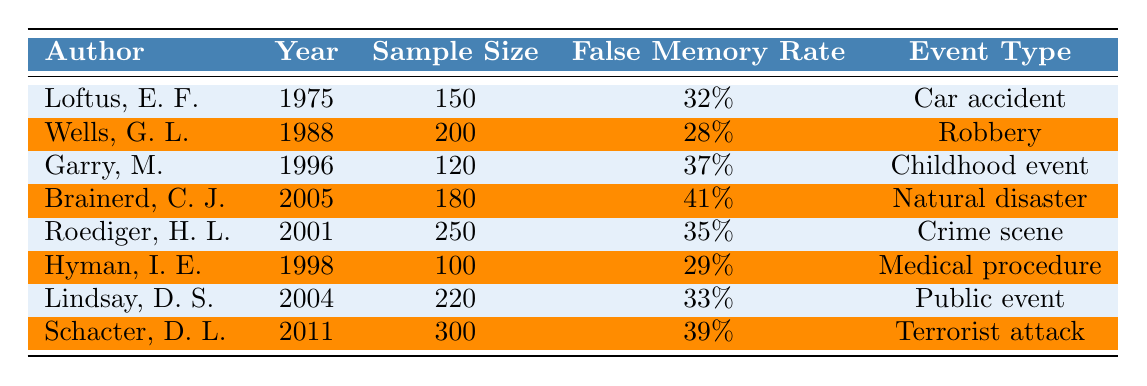What is the false memory rate for the study conducted by Brainerd, C. J.? The table lists the false memory rate column, and under Brainerd, C. J., it shows 41%.
Answer: 41% Which event type has the highest false memory rate according to the studies? By examining the false memory rates, the highest value is 41% for the event type "natural disaster" from Brainerd, C. J.
Answer: Natural disaster How many studies have a false memory rate of 35% or higher? The studies with false memory rates of 0.35 or higher are: Loftus (32%), Garry (37%), Brainerd (41%), Roediger (35%), Lindsay (33%), and Schacter (39%). This totals to 5 studies.
Answer: 5 What is the average sample size across all studies? The sample sizes are 150, 200, 120, 180, 250, 100, 220, and 300. Sum these values (150 + 200 + 120 + 180 + 250 + 100 + 220 + 300 = 1520) and divide by 8 (the number of studies), resulting in an average of 190.
Answer: 190 Is the false memory rate for the "terrorist attack" event higher than that of the "robbery" event? The false memory rate for "terrorist attack" by Schacter is 39% and for "robbery" by Wells is 28%. Since 39% is greater than 28%, it is true that the rate is higher.
Answer: Yes If we combine the false memory rates of the studies by Garry, M. and Hyman, I. E., what is the result? Garry has a false memory rate of 37% and Hyman has 29%. Adding these gives us 37% + 29% = 66%.
Answer: 66% Which author's study has the lowest sample size, and what is the associated false memory rate? Hyman, I. E. has the lowest sample size of 100 with a false memory rate of 29%.
Answer: Hyman, I. E.; 29% What year did Wells, G. L. conduct their study? By locating the row for Wells, G. L., the year listed is 1988.
Answer: 1988 How many studies covered events that are related to crime? Two studies focus on crime-related events: Wells, G. L. (robbery) and Roediger, H. L. (crime scene).
Answer: 2 What is the median false memory rate from the listed studies? The rates, in order, are 28%, 29%, 32%, 33%, 35%, 37%, 39%, and 41%. The middle values (33% and 35%) average to 34%.
Answer: 34% 